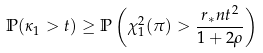Convert formula to latex. <formula><loc_0><loc_0><loc_500><loc_500>\mathbb { P } ( \kappa _ { 1 } > t ) \geq \mathbb { P } \left ( \chi _ { 1 } ^ { 2 } ( \pi ) > \frac { r _ { * } n t ^ { 2 } } { 1 + 2 \rho } \right )</formula> 